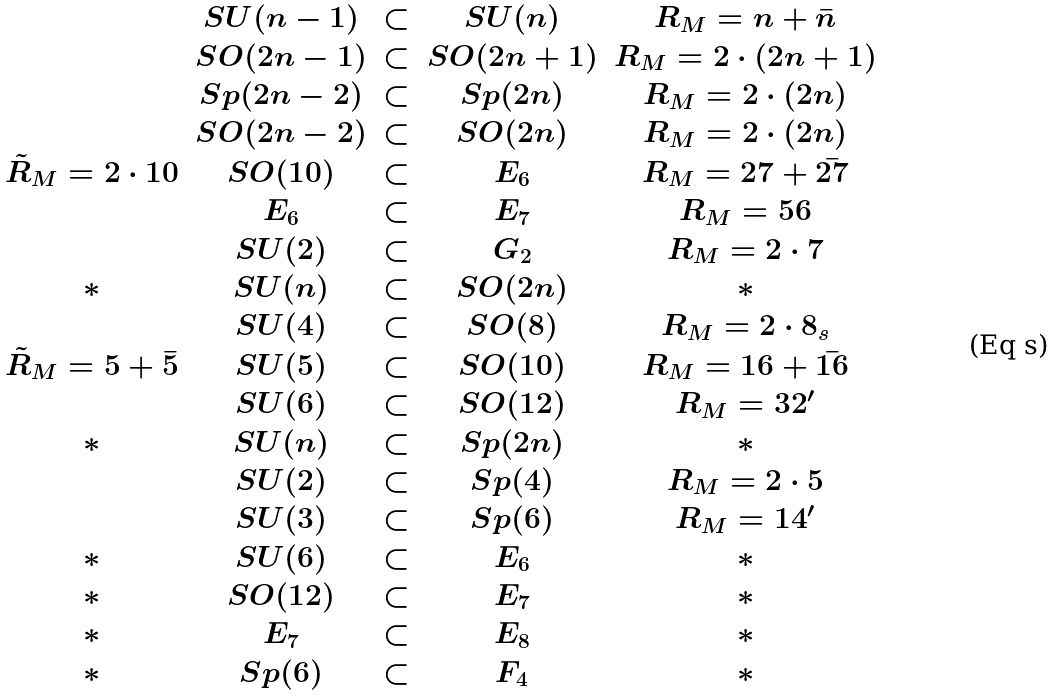<formula> <loc_0><loc_0><loc_500><loc_500>\begin{array} { c c c c c } & S U ( n - 1 ) & \subset & S U ( n ) & R _ { M } = { n } + { \bar { n } } \\ & S O ( 2 n - 1 ) & \subset & S O ( 2 n + 1 ) & R _ { M } = 2 \cdot { ( 2 n + 1 ) } \\ & S p ( 2 n - 2 ) & \subset & S p ( 2 n ) & R _ { M } = 2 \cdot { ( 2 n ) } \\ & S O ( 2 n - 2 ) & \subset & S O ( 2 n ) & R _ { M } = 2 \cdot { ( 2 n ) } \\ \tilde { R } _ { M } = 2 \cdot { 1 0 } & S O ( 1 0 ) & \subset & E _ { 6 } & R _ { M } = { 2 7 } + { \bar { 2 7 } } \\ & E _ { 6 } & \subset & E _ { 7 } & R _ { M } = { 5 6 } \\ & S U ( 2 ) & \subset & G _ { 2 } & R _ { M } = 2 \cdot { 7 } \\ \ast & S U ( n ) & \subset & S O ( 2 n ) & \ast \\ & S U ( 4 ) & \subset & S O ( 8 ) & R _ { M } = 2 \cdot { 8 } _ { s } \\ \tilde { R } _ { M } = { 5 } + { \bar { 5 } } & S U ( 5 ) & \subset & S O ( 1 0 ) & R _ { M } = { 1 6 } + { \bar { 1 6 } } \\ & S U ( 6 ) & \subset & S O ( 1 2 ) & R _ { M } = { 3 2 } ^ { \prime } \\ \ast & S U ( n ) & \subset & S p ( 2 n ) & \ast \\ & S U ( 2 ) & \subset & S p ( 4 ) & R _ { M } = 2 \cdot { 5 } \\ & S U ( 3 ) & \subset & S p ( 6 ) & R _ { M } = { 1 4 } ^ { \prime } \\ \ast & S U ( 6 ) & \subset & E _ { 6 } & \ast \\ \ast & S O ( 1 2 ) & \subset & E _ { 7 } & \ast \\ \ast & E _ { 7 } & \subset & E _ { 8 } & \ast \\ \ast & S p ( 6 ) & \subset & F _ { 4 } & \ast \end{array}</formula> 